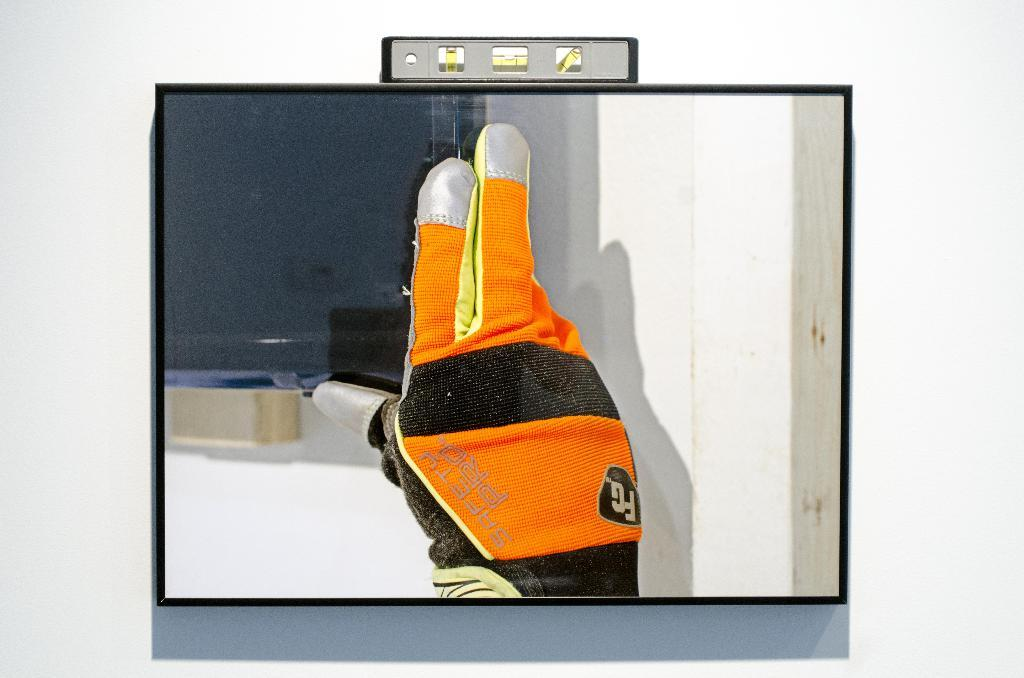What is located on the wall in the foreground of the image? There is a screen on a wall in the foreground of the image. What can be seen on the screen? A person's hand is visible on the screen. What is the person's hand wearing? The hand is wearing gloves. How is the hand positioned on the screen? The hand is holding the edge of the monitor. What type of spark can be seen coming from the person's wrist in the image? There is no spark visible in the image; the hand is simply holding the edge of the monitor. 